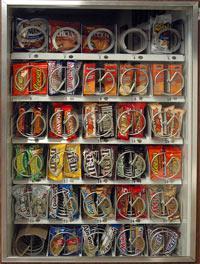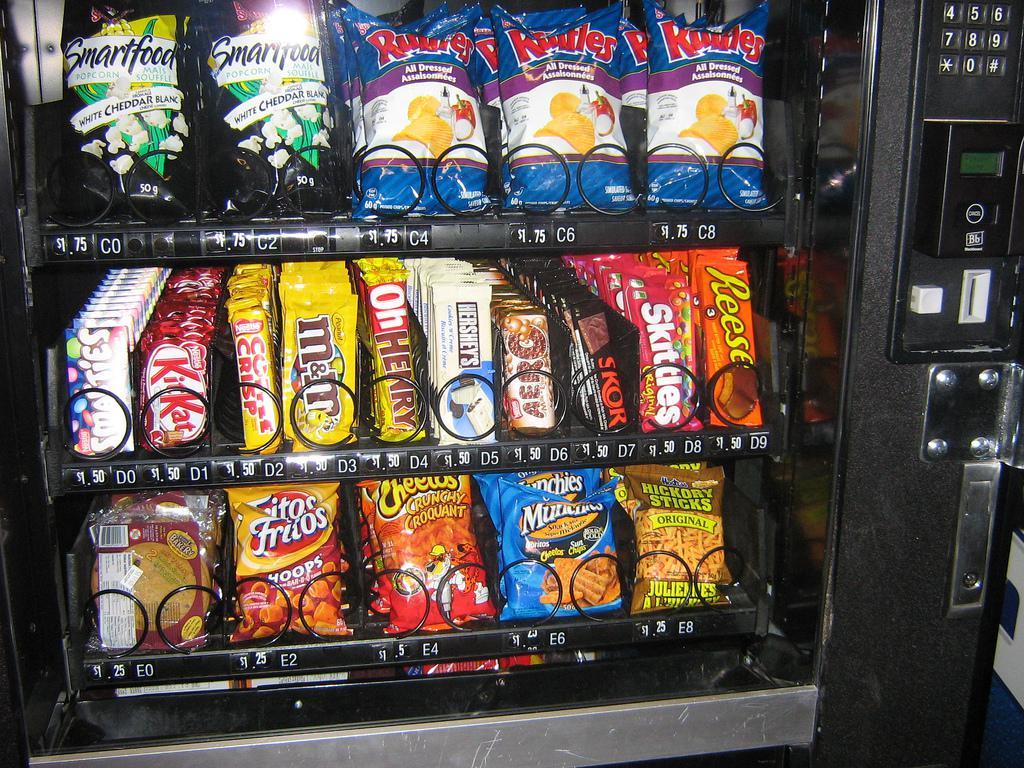The first image is the image on the left, the second image is the image on the right. Considering the images on both sides, is "Left image shows one vending machine displayed straight-on instead of at any angle." valid? Answer yes or no. Yes. The first image is the image on the left, the second image is the image on the right. Assess this claim about the two images: "A part of a human being's body is near a vending machine.". Correct or not? Answer yes or no. No. 